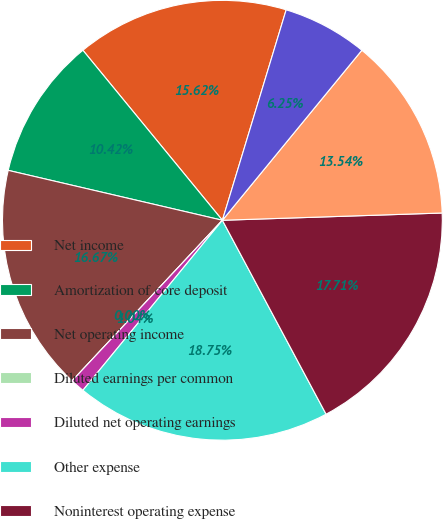Convert chart to OTSL. <chart><loc_0><loc_0><loc_500><loc_500><pie_chart><fcel>Net income<fcel>Amortization of core deposit<fcel>Net operating income<fcel>Diluted earnings per common<fcel>Diluted net operating earnings<fcel>Other expense<fcel>Noninterest operating expense<fcel>Average assets<fcel>Goodwill<nl><fcel>15.62%<fcel>10.42%<fcel>16.67%<fcel>0.0%<fcel>1.04%<fcel>18.75%<fcel>17.71%<fcel>13.54%<fcel>6.25%<nl></chart> 